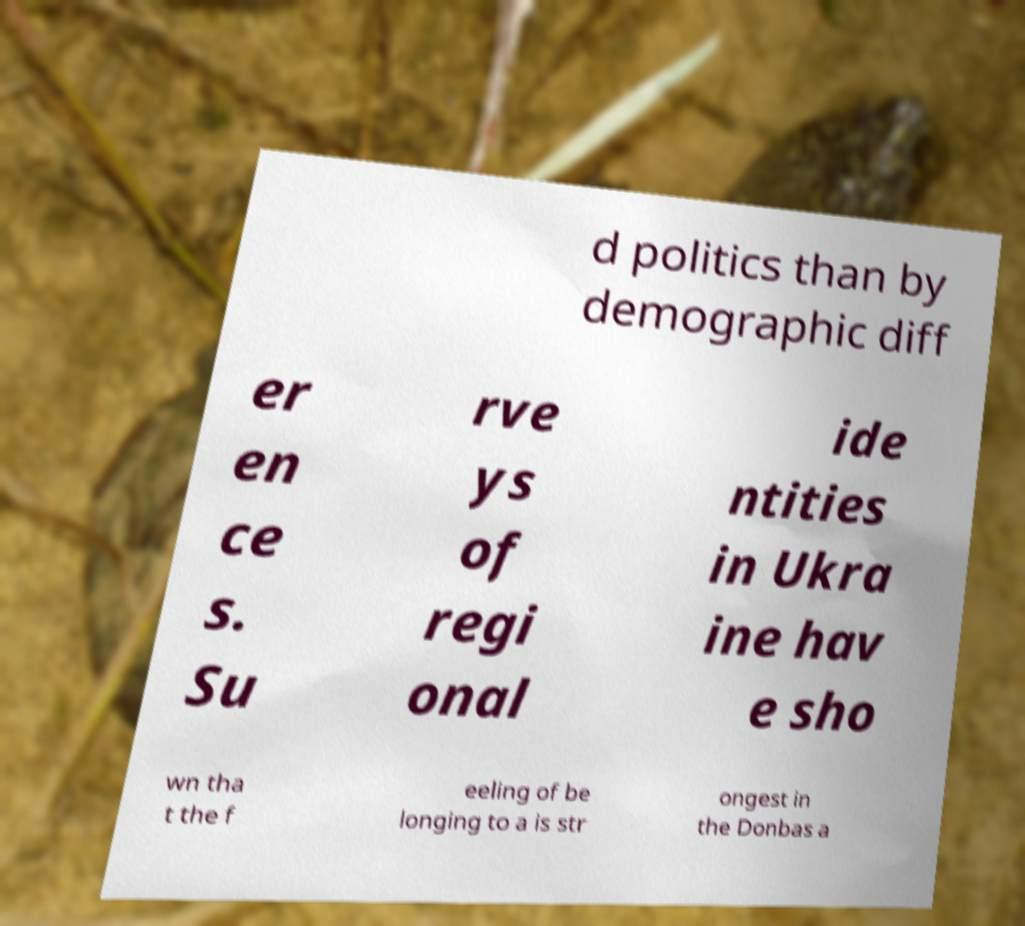Could you extract and type out the text from this image? d politics than by demographic diff er en ce s. Su rve ys of regi onal ide ntities in Ukra ine hav e sho wn tha t the f eeling of be longing to a is str ongest in the Donbas a 